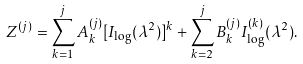<formula> <loc_0><loc_0><loc_500><loc_500>Z ^ { ( j ) } = \sum _ { k = 1 } ^ { j } A _ { k } ^ { ( j ) } [ I _ { \log } ( \lambda ^ { 2 } ) ] ^ { k } + \sum _ { k = 2 } ^ { j } B _ { k } ^ { ( j ) } I _ { \log } ^ { ( k ) } ( \lambda ^ { 2 } ) .</formula> 